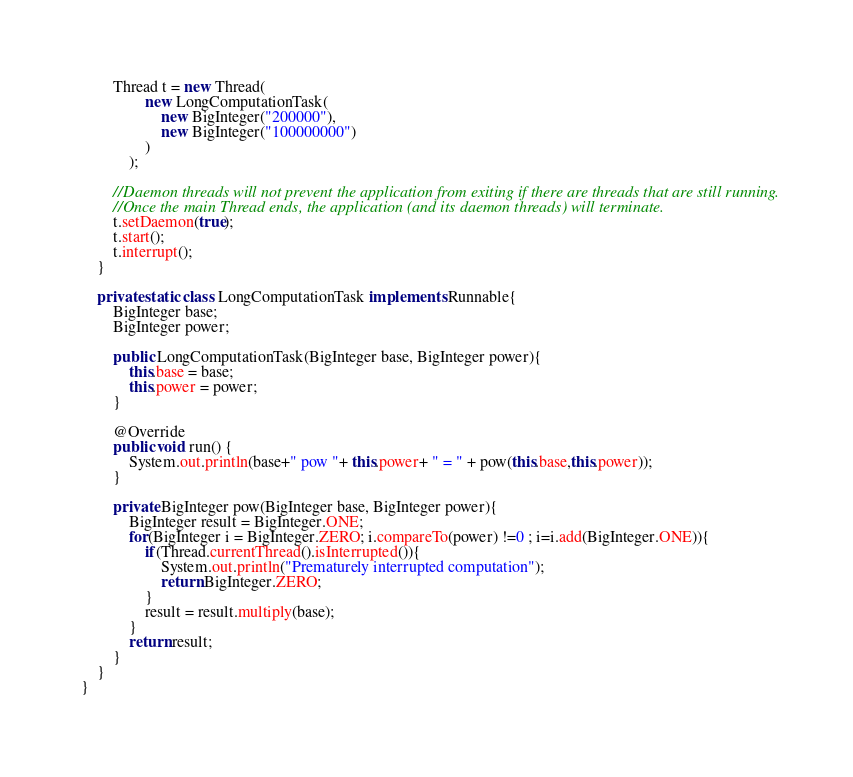<code> <loc_0><loc_0><loc_500><loc_500><_Java_>        Thread t = new Thread(
                new LongComputationTask(
                    new BigInteger("200000"),
                    new BigInteger("100000000")
                )
            );

        //Daemon threads will not prevent the application from exiting if there are threads that are still running.
        //Once the main Thread ends, the application (and its daemon threads) will terminate.
        t.setDaemon(true);
        t.start();
        t.interrupt();
    }

    private static class LongComputationTask implements Runnable{
        BigInteger base;
        BigInteger power;

        public LongComputationTask(BigInteger base, BigInteger power){
            this.base = base;
            this.power = power;
        }

        @Override
        public void run() {
            System.out.println(base+" pow "+ this.power+ " = " + pow(this.base,this.power));
        }

        private BigInteger pow(BigInteger base, BigInteger power){
            BigInteger result = BigInteger.ONE;
            for(BigInteger i = BigInteger.ZERO; i.compareTo(power) !=0 ; i=i.add(BigInteger.ONE)){
                if(Thread.currentThread().isInterrupted()){
                    System.out.println("Prematurely interrupted computation");
                    return BigInteger.ZERO;
                }
                result = result.multiply(base);
            }
            return result;
        }
    }
}
</code> 